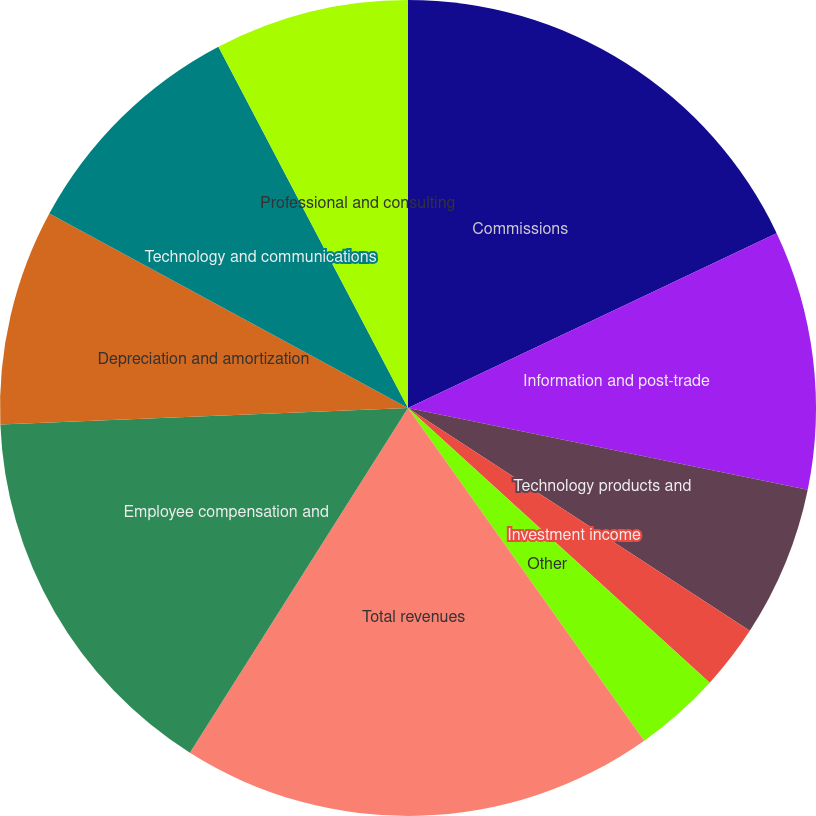<chart> <loc_0><loc_0><loc_500><loc_500><pie_chart><fcel>Commissions<fcel>Information and post-trade<fcel>Technology products and<fcel>Investment income<fcel>Other<fcel>Total revenues<fcel>Employee compensation and<fcel>Depreciation and amortization<fcel>Technology and communications<fcel>Professional and consulting<nl><fcel>17.95%<fcel>10.26%<fcel>5.98%<fcel>2.56%<fcel>3.42%<fcel>18.8%<fcel>15.38%<fcel>8.55%<fcel>9.4%<fcel>7.69%<nl></chart> 